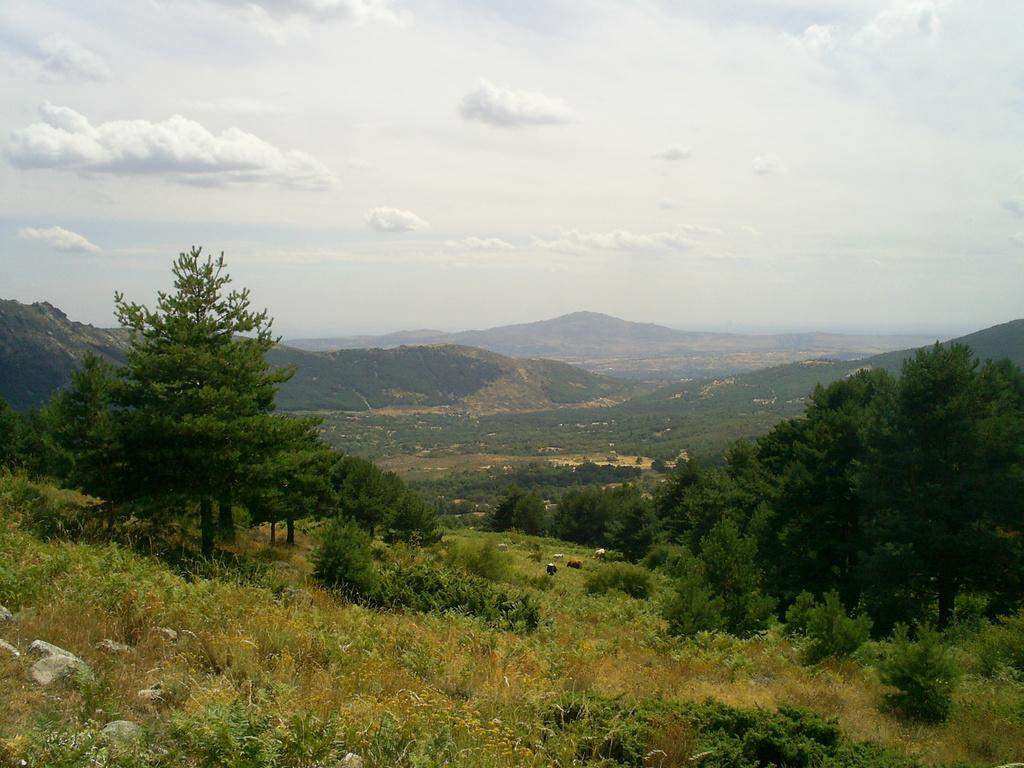What type of natural formation can be seen in the image? There are mountains in the image. What is present on the ground in the image? There are rocks and grass on the ground in the image. What are the animals in the image doing? The animals are eating grass in the image. What type of vegetation can be seen in the image? There are trees, bushes, and plants in the image. What is visible at the top of the image? The sky is visible at the top of the image. What is the condition of the sky in the image? The sky is cloudy in the image. What type of seed is being used to start a fire in the image? There is no seed or fire present in the image; it features mountains, rocks, animals, trees, bushes, plants, grass, and a cloudy sky. What type of sheet is covering the animals in the image? There is no sheet covering the animals in the image; they are eating grass in the open. 